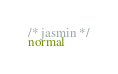Convert code to text. <code><loc_0><loc_0><loc_500><loc_500><_JavaScript_>/* jasmin */
normal</code> 